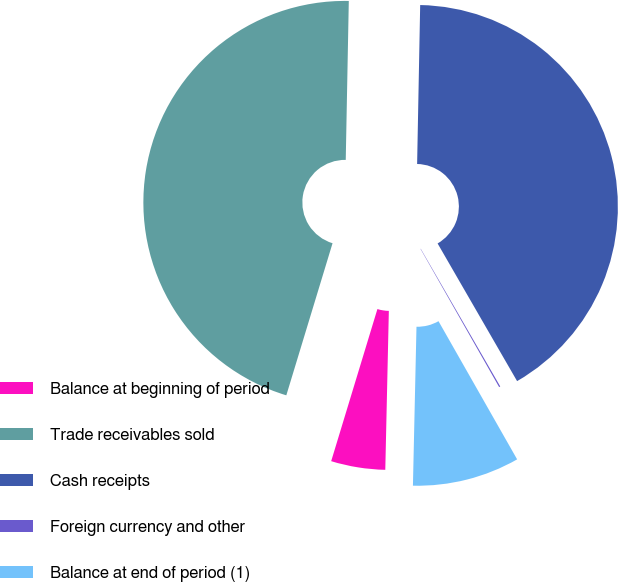<chart> <loc_0><loc_0><loc_500><loc_500><pie_chart><fcel>Balance at beginning of period<fcel>Trade receivables sold<fcel>Cash receipts<fcel>Foreign currency and other<fcel>Balance at end of period (1)<nl><fcel>4.34%<fcel>45.61%<fcel>41.36%<fcel>0.1%<fcel>8.59%<nl></chart> 